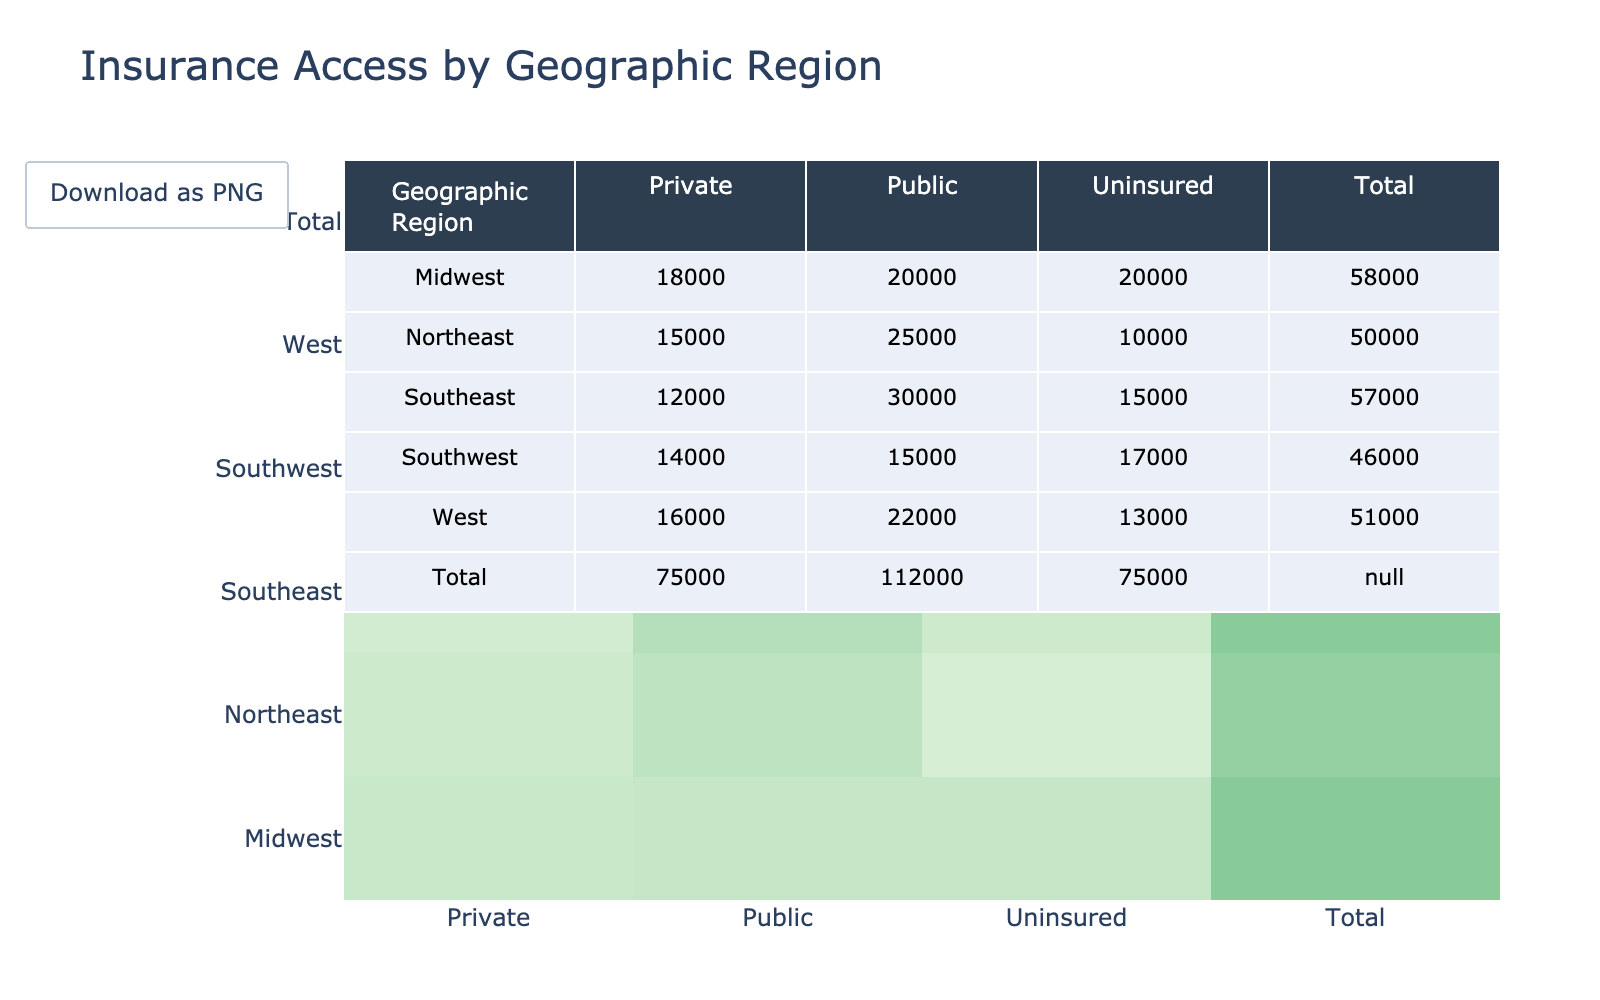What is the total number of individuals insured by Public insurance in the Southeast region? In the Southeast region, the Public insurance category has 30,000 individuals as indicated in the table.
Answer: 30,000 How many individuals are Uninsured in the Midwest? In the Midwest region, the table shows that there are 20,000 individuals who are Uninsured.
Answer: 20,000 Which region has the highest number of individuals with Private insurance? By comparing Private insurance numbers across regions, the Northeast has 15,000, Southeast has 12,000, Midwest has 18,000, Southwest has 14,000, and the West has 16,000. The highest number is therefore in the Midwest with 18,000.
Answer: Midwest Is the total number of individuals in the West greater than that in the Northeast? To determine if this statement is true, we sum the individuals for each region. West totals 22,000 (Public) + 16,000 (Private) + 13,000 (Uninsured) = 51,000. Northeast totals 25,000 (Public) + 15,000 (Private) + 10,000 (Uninsured) = 50,000. Since 51,000 is greater than 50,000, the statement is true.
Answer: Yes What is the average number of individuals across all regions with Uninsured status? Summing the Uninsured counts gives 10,000 (Northeast) + 15,000 (Southeast) + 20,000 (Midwest) + 17,000 (Southwest) + 13,000 (West) = 75,000. Since there are 5 regions, the average is 75,000 / 5 = 15,000.
Answer: 15,000 Which geographic region has the lowest total number of individuals insured by Public insurance? The Public insurance numbers by region are as follows: Northeast (25,000), Southeast (30,000), Midwest (20,000), Southwest (15,000), and West (22,000). The smallest number is 15,000 in the Southwest region.
Answer: Southwest Calculate the difference between the total number of individuals with Private and Public insurance in the entire dataset. The total for Private insurance is 15,000 (Northeast) + 12,000 (Southeast) + 18,000 (Midwest) + 14,000 (Southwest) + 16,000 (West) = 75,000. For Public insurance, total is 25,000 + 30,000 + 20,000 + 15,000 + 22,000 = 112,000. The difference is 112,000 - 75,000 = 37,000.
Answer: 37,000 Is there any region where the number of Uninsured is less than the number with Public insurance? By checking each region, we note: Northeast (10,000 Uninsured vs. 25,000 Public), Southeast (15,000 vs. 30,000), Midwest (20,000 vs. 20,000), Southwest (17,000 vs. 15,000), West (13,000 vs. 22,000). The Southwest is the only region where Uninsured (17,000) exceeds Public (15,000), thus there are regions where Uninsured is less.
Answer: Yes What percentage of the total individuals in the Midwest are Uninsured? The total number of individuals in the Midwest is the sum of all types of insurance: 20,000 (Public) + 18,000 (Private) + 20,000 (Uninsured) = 58,000. The percentage of Uninsured is (20,000 / 58,000) * 100 ≈ 34.48%.
Answer: 34.48% 